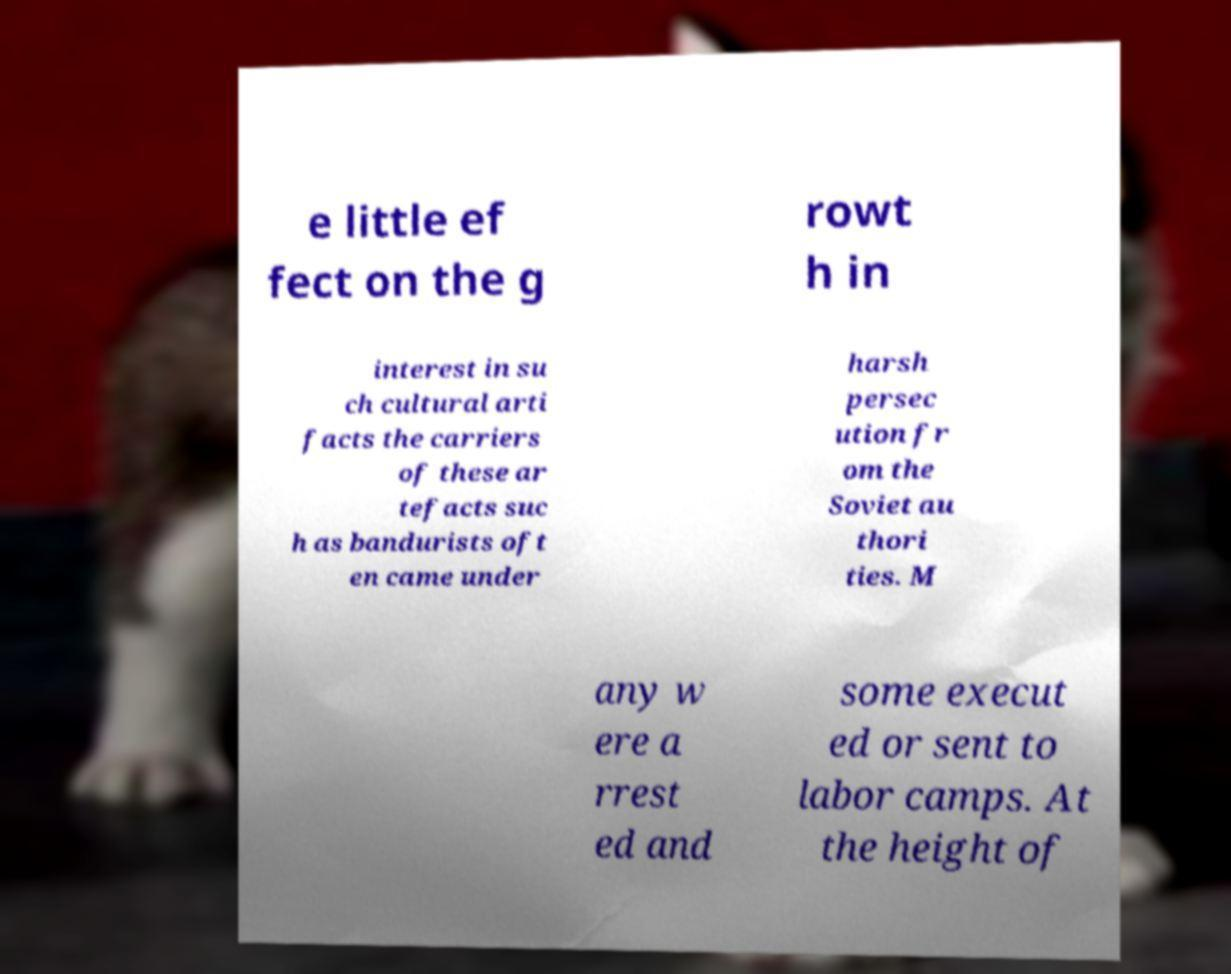Please read and relay the text visible in this image. What does it say? e little ef fect on the g rowt h in interest in su ch cultural arti facts the carriers of these ar tefacts suc h as bandurists oft en came under harsh persec ution fr om the Soviet au thori ties. M any w ere a rrest ed and some execut ed or sent to labor camps. At the height of 